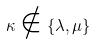<formula> <loc_0><loc_0><loc_500><loc_500>\kappa \notin \{ \lambda , \mu \}</formula> 